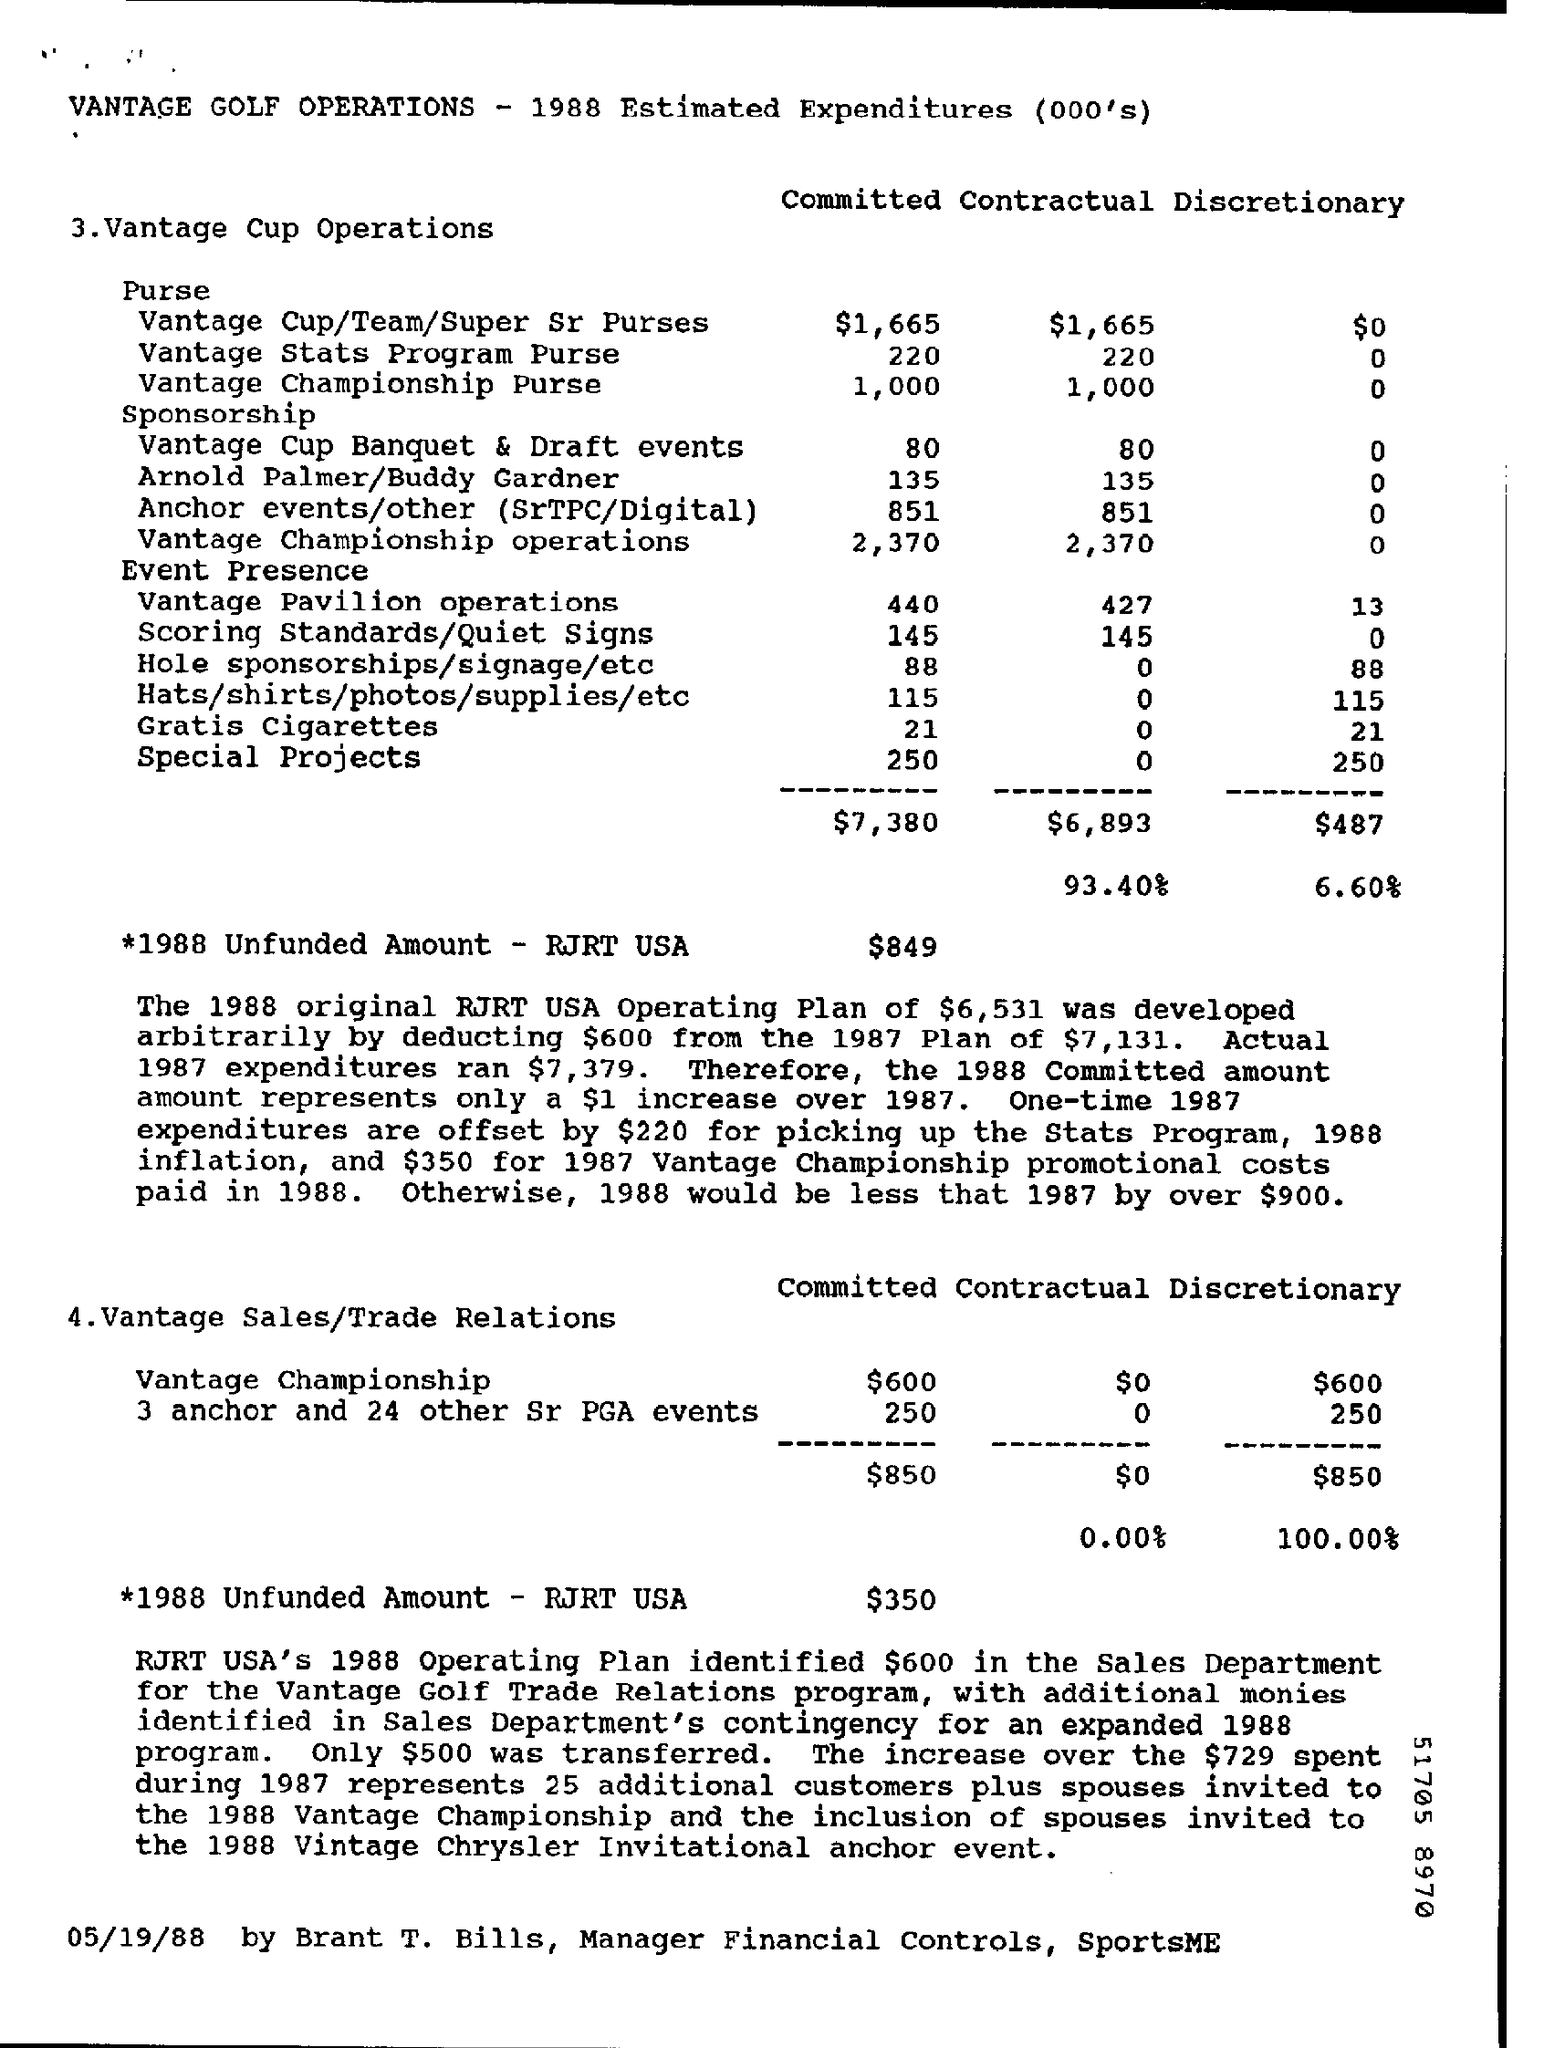Outline some significant characteristics in this image. Brant T. Bills is the Manager of Financial Controls at SportsME. The 1988 unfunded amount for Vantage cup operations in the United States, as reported by RJRT USA, is $849. The Committed Vantage Championship purse is expected to cost $1,000. The committed cost for Vantage Sales and Trade Relations for the Vantage Championship is $600. The actual expenditures in 1987 were $7,379. 